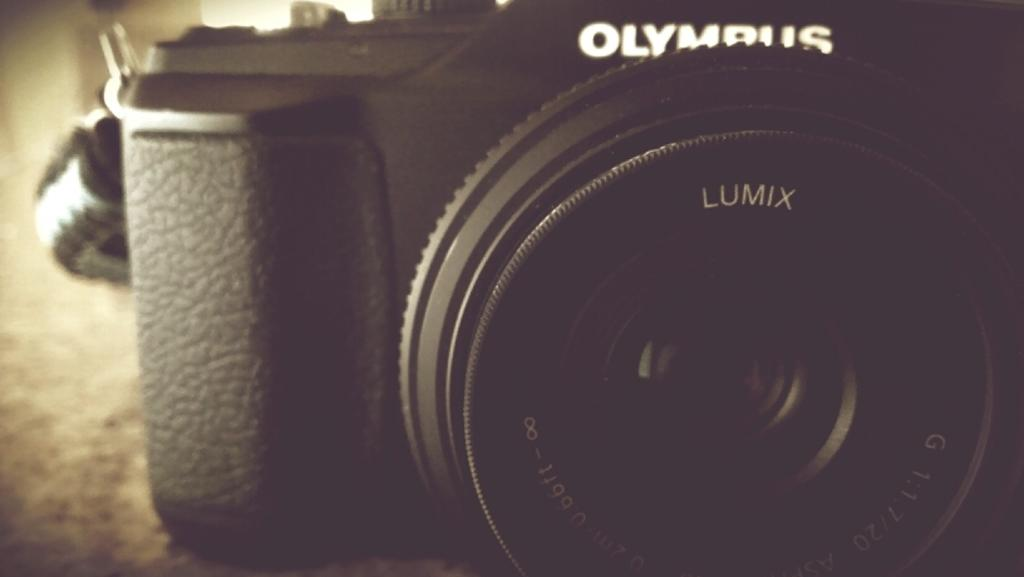What type of camera is visible in the image? There is a black color camera in the image. What brand is the camera? The camera has "LUMIX" written on it, indicating that it is a Lumix camera. What type of pie is being photographed by the camera in the image? There is no pie present in the image; it only features a black color camera with "LUMIX" written on it. 